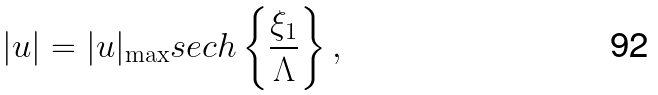<formula> <loc_0><loc_0><loc_500><loc_500>| u | = | u | _ { \max } s e c h \left \{ \frac { \xi _ { 1 } } { \Lambda } \right \} ,</formula> 